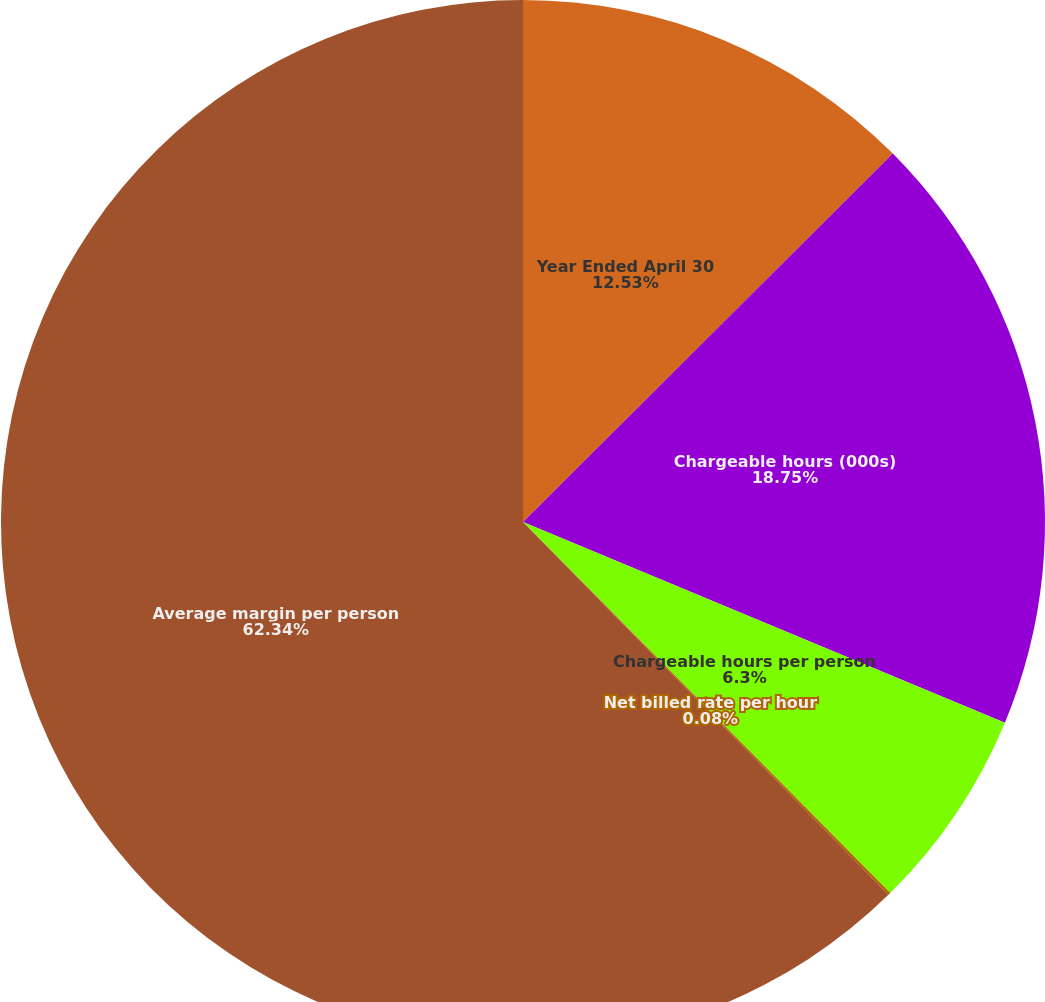<chart> <loc_0><loc_0><loc_500><loc_500><pie_chart><fcel>Year Ended April 30<fcel>Chargeable hours (000s)<fcel>Chargeable hours per person<fcel>Net billed rate per hour<fcel>Average margin per person<nl><fcel>12.53%<fcel>18.75%<fcel>6.3%<fcel>0.08%<fcel>62.34%<nl></chart> 